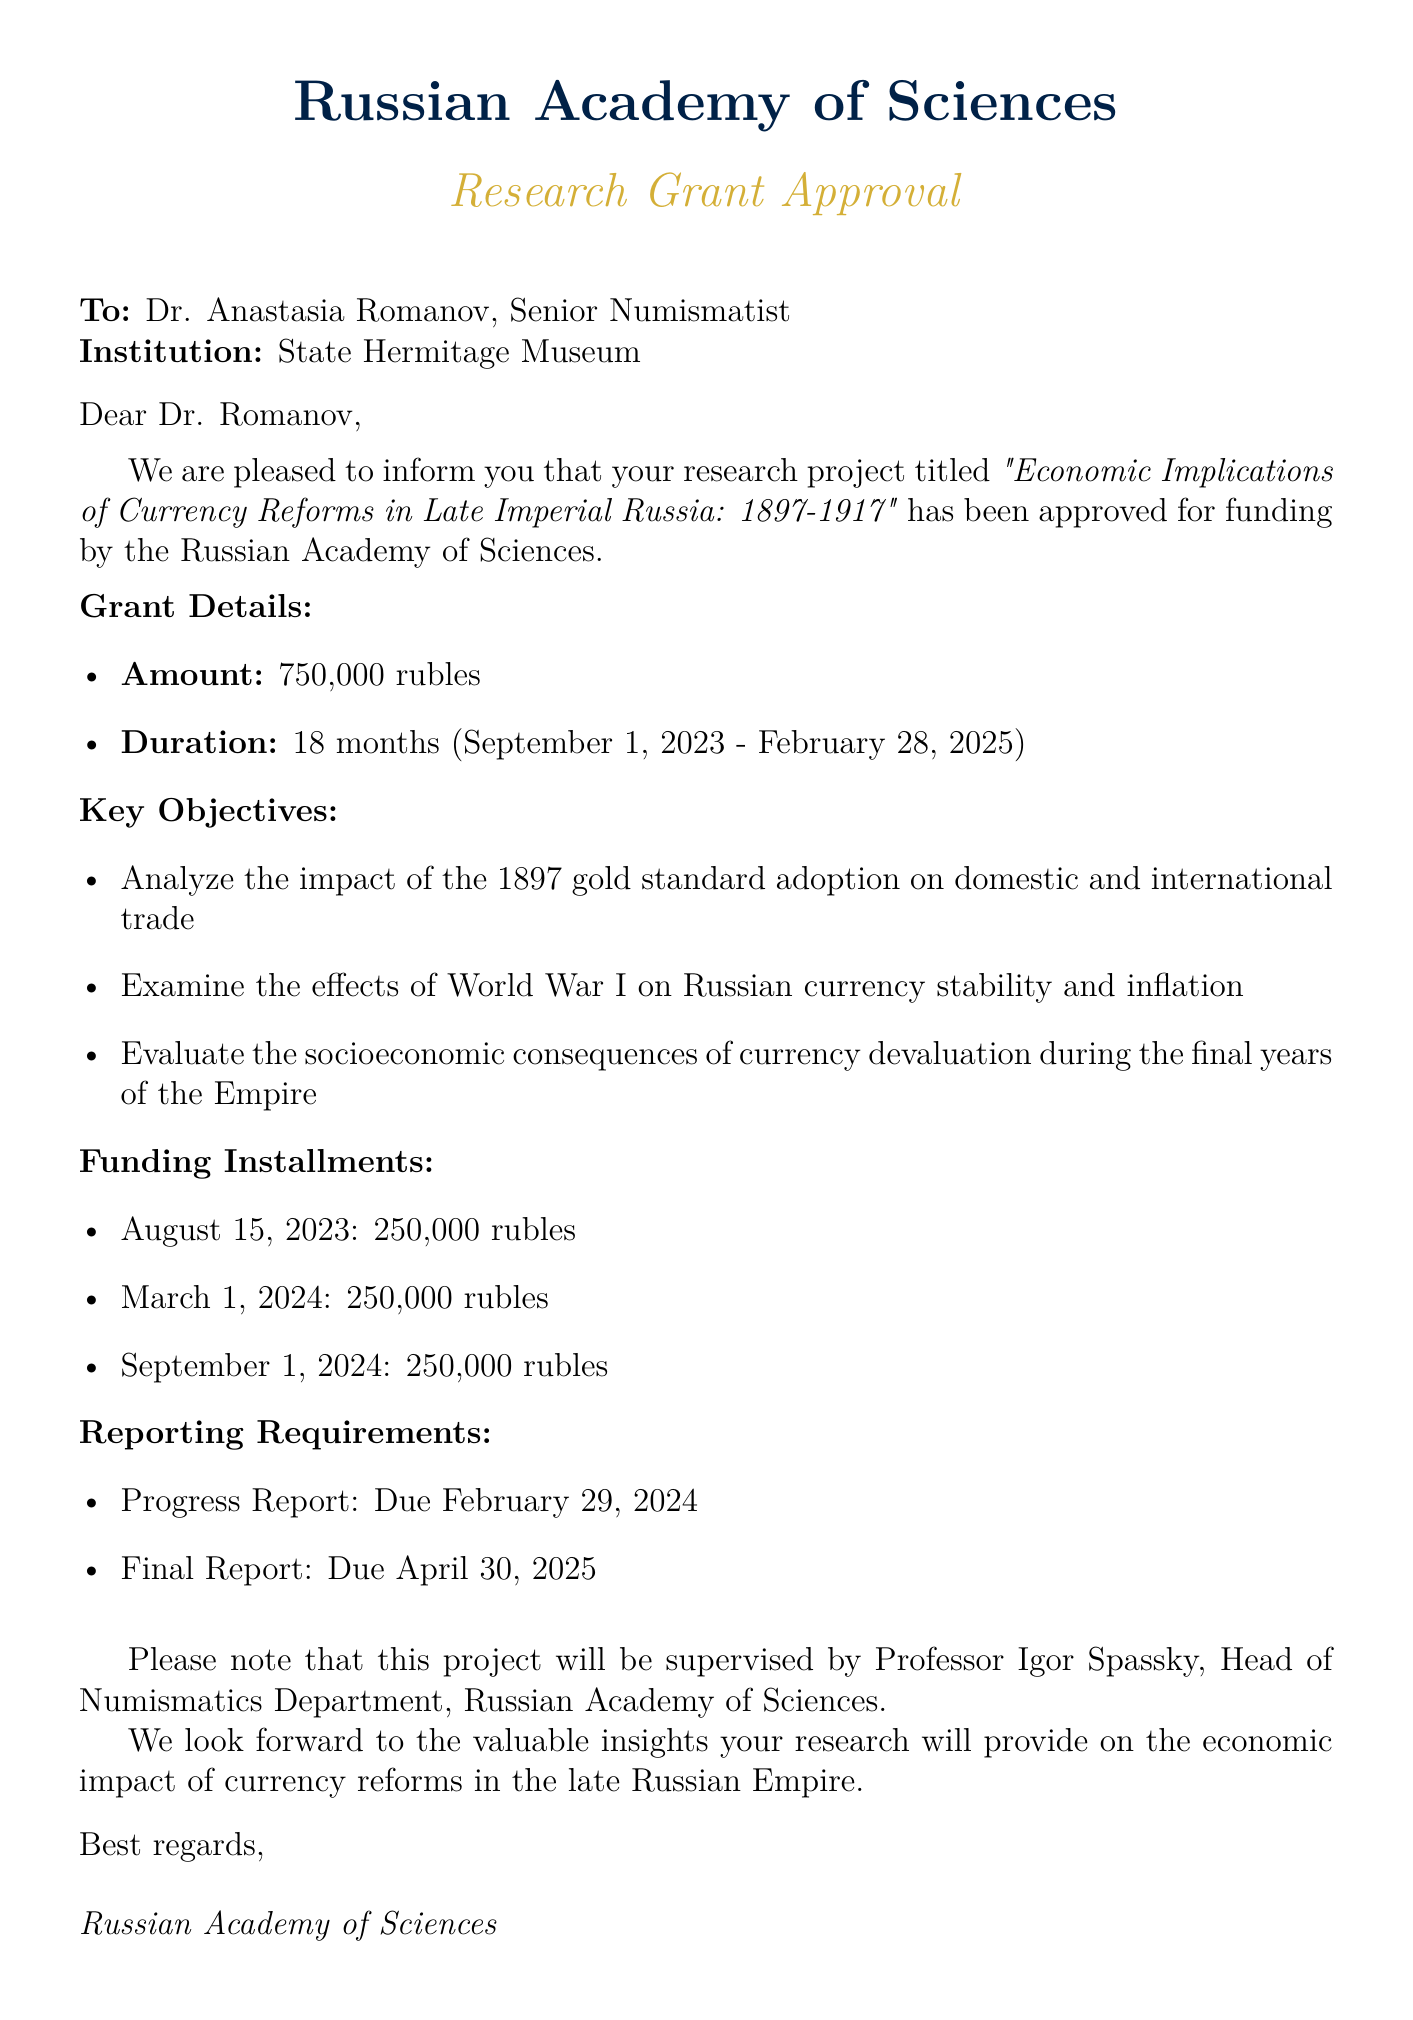What is the title of the project? The title of the project is explicitly mentioned in the document.
Answer: Economic Implications of Currency Reforms in Late Imperial Russia: 1897-1917 Who is the recipient of the grant approval letter? The recipient's name is provided at the beginning of the document.
Answer: Dr. Anastasia Romanov What is the total grant amount? The document specifies the grant amount clearly as part of the grant details.
Answer: 750,000 rubles What is the project duration? The project duration is included in the grant details section.
Answer: 18 months When is the final report due? The due date for the final report is listed under reporting requirements.
Answer: April 30, 2025 How many installments of funding will be provided? The funding installments are outlined in a list in the document.
Answer: Three installments Who will supervise the project? The supervisor's name and title are mentioned towards the end of the document.
Answer: Professor Igor Spassky What is the start date of the project? The start date is explicitly mentioned in the grant duration.
Answer: September 1, 2023 What is one of the key objectives of the project? Key objectives are listed in a bulleted format in the document.
Answer: Analyze the impact of the 1897 gold standard adoption on domestic and international trade 